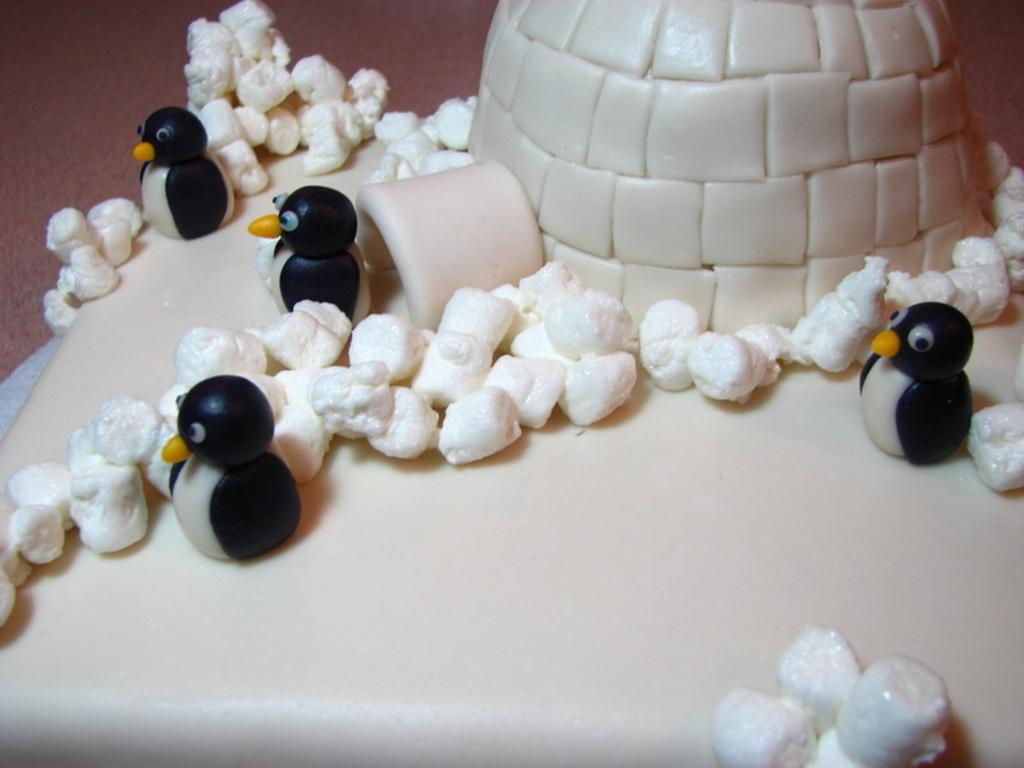What is the main subject of the image? The main subject of the image is a cake. What decorations are on the cake? The cake has penguins, marshmallows, and an igloo on it. What type of bubble is floating above the cake in the image? There is no bubble present in the image. How does the behavior of the penguins on the cake differ from real penguins? The penguins on the cake are decorations and do not exhibit any behavior, as they are not real penguins. 